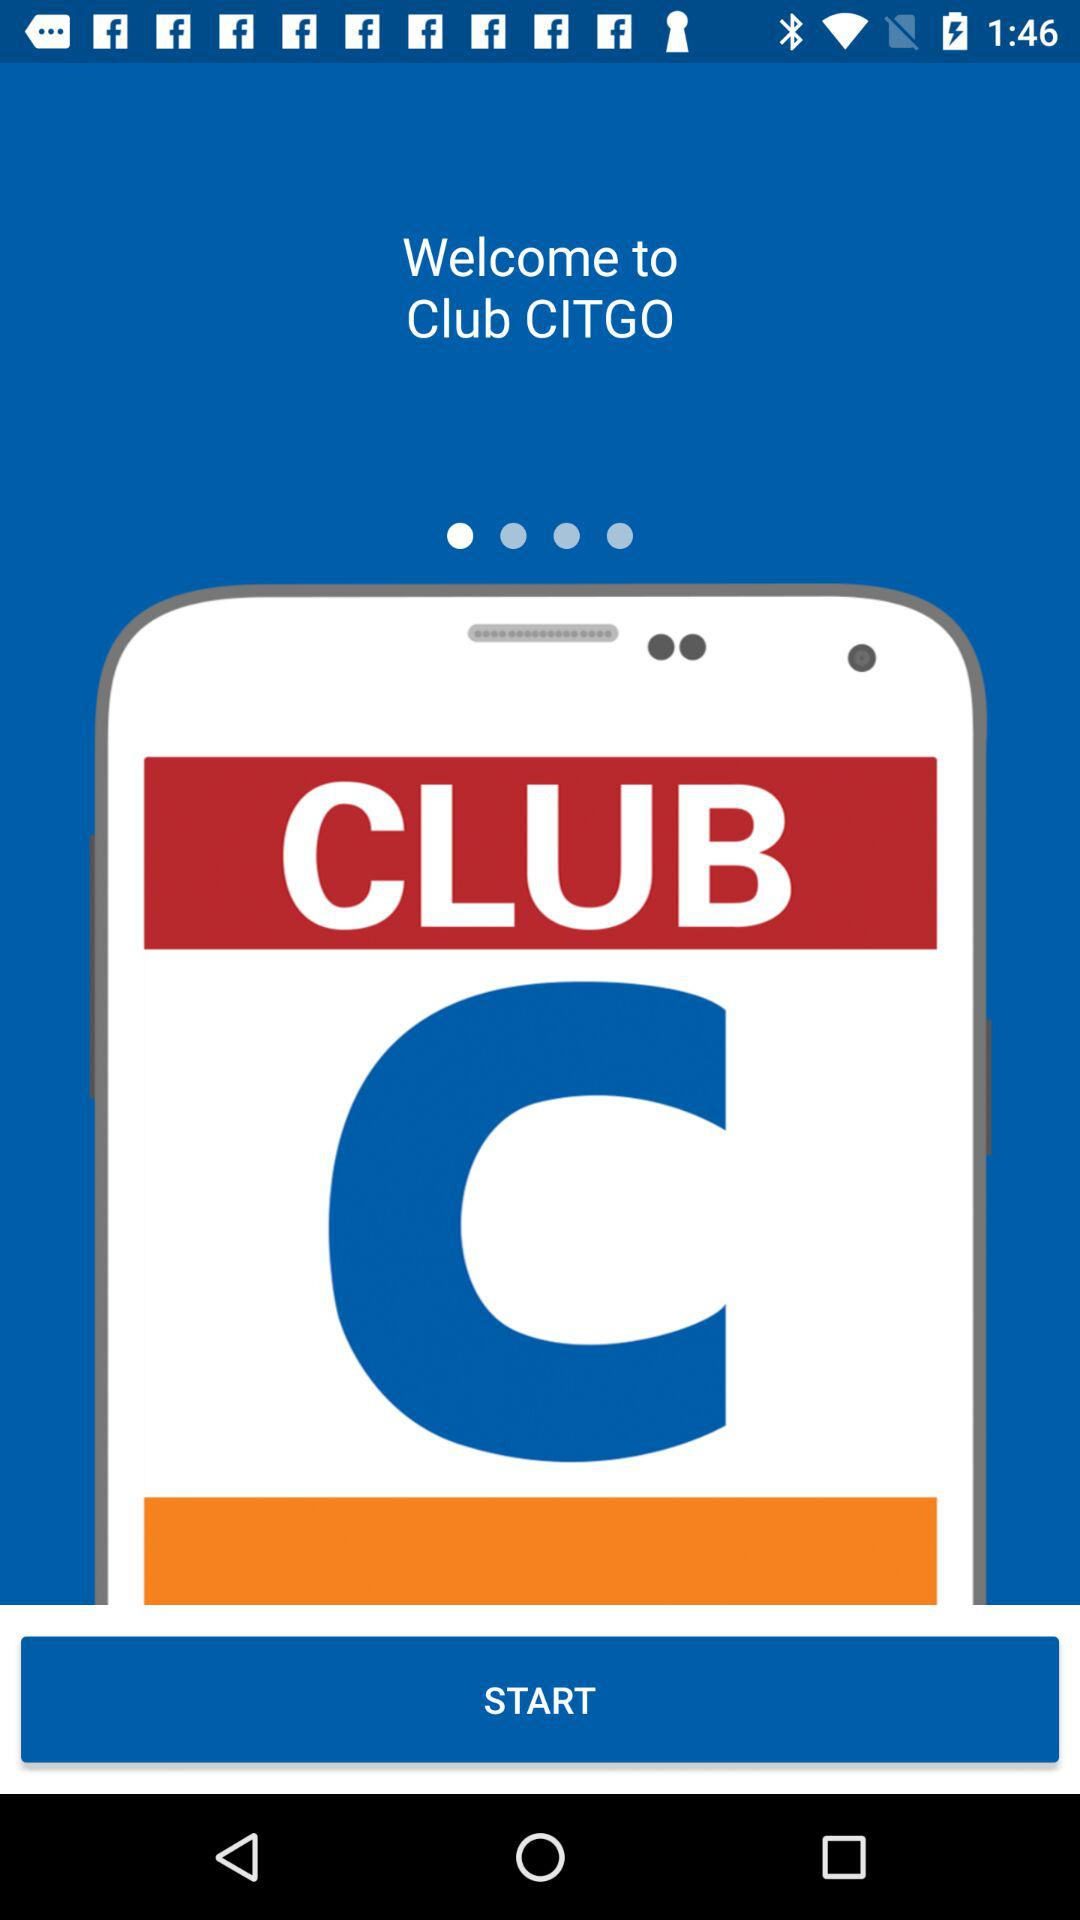What is the name of the application? The name of the application is "Club CITGO". 